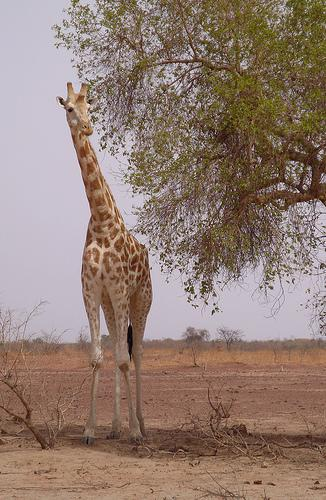Question: what animal is in the picture?
Choices:
A. An elephant.
B. A giraffe.
C. A dog.
D. A cat.
Answer with the letter. Answer: B Question: how many ears are in this picture?
Choices:
A. One.
B. Two.
C. None.
D. Three.
Answer with the letter. Answer: B Question: what is the pattern on the giraffe's fur?
Choices:
A. Brown.
B. Spots.
C. Yellow.
D. Yellow and brown.
Answer with the letter. Answer: B 